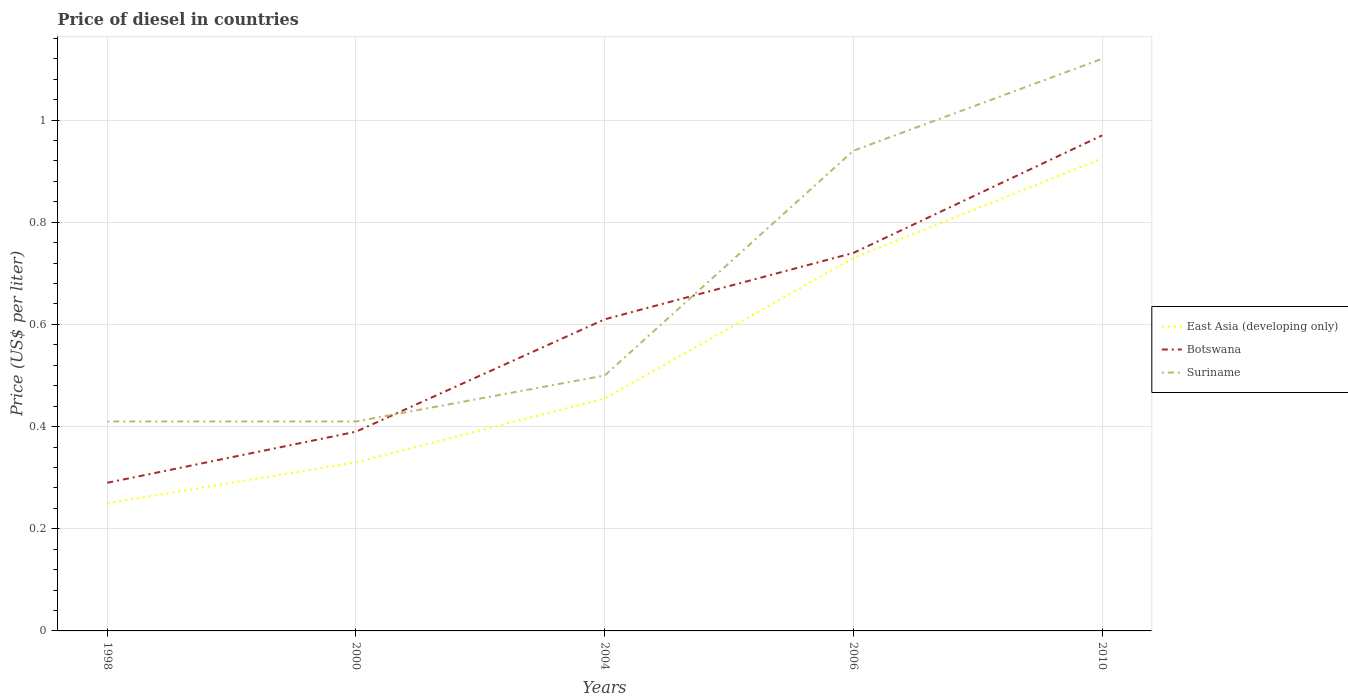Across all years, what is the maximum price of diesel in Botswana?
Your response must be concise. 0.29. What is the total price of diesel in East Asia (developing only) in the graph?
Keep it short and to the point. -0.59. What is the difference between the highest and the second highest price of diesel in Suriname?
Provide a succinct answer. 0.71. How many lines are there?
Give a very brief answer. 3. Does the graph contain any zero values?
Offer a terse response. No. Does the graph contain grids?
Offer a very short reply. Yes. Where does the legend appear in the graph?
Keep it short and to the point. Center right. How are the legend labels stacked?
Offer a terse response. Vertical. What is the title of the graph?
Your response must be concise. Price of diesel in countries. Does "Sao Tome and Principe" appear as one of the legend labels in the graph?
Your response must be concise. No. What is the label or title of the X-axis?
Offer a terse response. Years. What is the label or title of the Y-axis?
Offer a terse response. Price (US$ per liter). What is the Price (US$ per liter) of Botswana in 1998?
Offer a terse response. 0.29. What is the Price (US$ per liter) in Suriname in 1998?
Your answer should be compact. 0.41. What is the Price (US$ per liter) in East Asia (developing only) in 2000?
Offer a very short reply. 0.33. What is the Price (US$ per liter) in Botswana in 2000?
Ensure brevity in your answer.  0.39. What is the Price (US$ per liter) in Suriname in 2000?
Provide a succinct answer. 0.41. What is the Price (US$ per liter) of East Asia (developing only) in 2004?
Provide a succinct answer. 0.46. What is the Price (US$ per liter) in Botswana in 2004?
Provide a succinct answer. 0.61. What is the Price (US$ per liter) in East Asia (developing only) in 2006?
Provide a short and direct response. 0.73. What is the Price (US$ per liter) in Botswana in 2006?
Your answer should be compact. 0.74. What is the Price (US$ per liter) of Suriname in 2006?
Offer a very short reply. 0.94. What is the Price (US$ per liter) of East Asia (developing only) in 2010?
Your answer should be very brief. 0.93. What is the Price (US$ per liter) of Botswana in 2010?
Your response must be concise. 0.97. What is the Price (US$ per liter) of Suriname in 2010?
Ensure brevity in your answer.  1.12. Across all years, what is the maximum Price (US$ per liter) of East Asia (developing only)?
Offer a very short reply. 0.93. Across all years, what is the maximum Price (US$ per liter) of Suriname?
Offer a very short reply. 1.12. Across all years, what is the minimum Price (US$ per liter) in East Asia (developing only)?
Your answer should be very brief. 0.25. Across all years, what is the minimum Price (US$ per liter) in Botswana?
Your answer should be compact. 0.29. Across all years, what is the minimum Price (US$ per liter) of Suriname?
Ensure brevity in your answer.  0.41. What is the total Price (US$ per liter) in East Asia (developing only) in the graph?
Give a very brief answer. 2.69. What is the total Price (US$ per liter) in Botswana in the graph?
Provide a succinct answer. 3. What is the total Price (US$ per liter) in Suriname in the graph?
Make the answer very short. 3.38. What is the difference between the Price (US$ per liter) in East Asia (developing only) in 1998 and that in 2000?
Offer a very short reply. -0.08. What is the difference between the Price (US$ per liter) of Suriname in 1998 and that in 2000?
Your answer should be very brief. 0. What is the difference between the Price (US$ per liter) of East Asia (developing only) in 1998 and that in 2004?
Keep it short and to the point. -0.2. What is the difference between the Price (US$ per liter) of Botswana in 1998 and that in 2004?
Your answer should be compact. -0.32. What is the difference between the Price (US$ per liter) of Suriname in 1998 and that in 2004?
Give a very brief answer. -0.09. What is the difference between the Price (US$ per liter) of East Asia (developing only) in 1998 and that in 2006?
Provide a short and direct response. -0.48. What is the difference between the Price (US$ per liter) in Botswana in 1998 and that in 2006?
Provide a succinct answer. -0.45. What is the difference between the Price (US$ per liter) in Suriname in 1998 and that in 2006?
Provide a succinct answer. -0.53. What is the difference between the Price (US$ per liter) of East Asia (developing only) in 1998 and that in 2010?
Give a very brief answer. -0.68. What is the difference between the Price (US$ per liter) of Botswana in 1998 and that in 2010?
Your answer should be compact. -0.68. What is the difference between the Price (US$ per liter) in Suriname in 1998 and that in 2010?
Your answer should be very brief. -0.71. What is the difference between the Price (US$ per liter) of East Asia (developing only) in 2000 and that in 2004?
Keep it short and to the point. -0.12. What is the difference between the Price (US$ per liter) of Botswana in 2000 and that in 2004?
Your response must be concise. -0.22. What is the difference between the Price (US$ per liter) in Suriname in 2000 and that in 2004?
Offer a very short reply. -0.09. What is the difference between the Price (US$ per liter) in East Asia (developing only) in 2000 and that in 2006?
Provide a short and direct response. -0.4. What is the difference between the Price (US$ per liter) of Botswana in 2000 and that in 2006?
Offer a terse response. -0.35. What is the difference between the Price (US$ per liter) of Suriname in 2000 and that in 2006?
Your answer should be very brief. -0.53. What is the difference between the Price (US$ per liter) of East Asia (developing only) in 2000 and that in 2010?
Your answer should be very brief. -0.59. What is the difference between the Price (US$ per liter) of Botswana in 2000 and that in 2010?
Keep it short and to the point. -0.58. What is the difference between the Price (US$ per liter) in Suriname in 2000 and that in 2010?
Keep it short and to the point. -0.71. What is the difference between the Price (US$ per liter) in East Asia (developing only) in 2004 and that in 2006?
Provide a short and direct response. -0.28. What is the difference between the Price (US$ per liter) in Botswana in 2004 and that in 2006?
Ensure brevity in your answer.  -0.13. What is the difference between the Price (US$ per liter) in Suriname in 2004 and that in 2006?
Keep it short and to the point. -0.44. What is the difference between the Price (US$ per liter) of East Asia (developing only) in 2004 and that in 2010?
Provide a succinct answer. -0.47. What is the difference between the Price (US$ per liter) in Botswana in 2004 and that in 2010?
Your response must be concise. -0.36. What is the difference between the Price (US$ per liter) of Suriname in 2004 and that in 2010?
Your answer should be compact. -0.62. What is the difference between the Price (US$ per liter) in East Asia (developing only) in 2006 and that in 2010?
Give a very brief answer. -0.2. What is the difference between the Price (US$ per liter) in Botswana in 2006 and that in 2010?
Keep it short and to the point. -0.23. What is the difference between the Price (US$ per liter) of Suriname in 2006 and that in 2010?
Your answer should be compact. -0.18. What is the difference between the Price (US$ per liter) in East Asia (developing only) in 1998 and the Price (US$ per liter) in Botswana in 2000?
Give a very brief answer. -0.14. What is the difference between the Price (US$ per liter) of East Asia (developing only) in 1998 and the Price (US$ per liter) of Suriname in 2000?
Offer a terse response. -0.16. What is the difference between the Price (US$ per liter) of Botswana in 1998 and the Price (US$ per liter) of Suriname in 2000?
Your answer should be compact. -0.12. What is the difference between the Price (US$ per liter) in East Asia (developing only) in 1998 and the Price (US$ per liter) in Botswana in 2004?
Provide a succinct answer. -0.36. What is the difference between the Price (US$ per liter) of Botswana in 1998 and the Price (US$ per liter) of Suriname in 2004?
Your response must be concise. -0.21. What is the difference between the Price (US$ per liter) of East Asia (developing only) in 1998 and the Price (US$ per liter) of Botswana in 2006?
Provide a succinct answer. -0.49. What is the difference between the Price (US$ per liter) of East Asia (developing only) in 1998 and the Price (US$ per liter) of Suriname in 2006?
Ensure brevity in your answer.  -0.69. What is the difference between the Price (US$ per liter) in Botswana in 1998 and the Price (US$ per liter) in Suriname in 2006?
Your answer should be very brief. -0.65. What is the difference between the Price (US$ per liter) in East Asia (developing only) in 1998 and the Price (US$ per liter) in Botswana in 2010?
Give a very brief answer. -0.72. What is the difference between the Price (US$ per liter) in East Asia (developing only) in 1998 and the Price (US$ per liter) in Suriname in 2010?
Offer a terse response. -0.87. What is the difference between the Price (US$ per liter) in Botswana in 1998 and the Price (US$ per liter) in Suriname in 2010?
Your answer should be very brief. -0.83. What is the difference between the Price (US$ per liter) in East Asia (developing only) in 2000 and the Price (US$ per liter) in Botswana in 2004?
Your answer should be compact. -0.28. What is the difference between the Price (US$ per liter) in East Asia (developing only) in 2000 and the Price (US$ per liter) in Suriname in 2004?
Make the answer very short. -0.17. What is the difference between the Price (US$ per liter) of Botswana in 2000 and the Price (US$ per liter) of Suriname in 2004?
Provide a succinct answer. -0.11. What is the difference between the Price (US$ per liter) of East Asia (developing only) in 2000 and the Price (US$ per liter) of Botswana in 2006?
Make the answer very short. -0.41. What is the difference between the Price (US$ per liter) of East Asia (developing only) in 2000 and the Price (US$ per liter) of Suriname in 2006?
Ensure brevity in your answer.  -0.61. What is the difference between the Price (US$ per liter) of Botswana in 2000 and the Price (US$ per liter) of Suriname in 2006?
Ensure brevity in your answer.  -0.55. What is the difference between the Price (US$ per liter) of East Asia (developing only) in 2000 and the Price (US$ per liter) of Botswana in 2010?
Ensure brevity in your answer.  -0.64. What is the difference between the Price (US$ per liter) in East Asia (developing only) in 2000 and the Price (US$ per liter) in Suriname in 2010?
Ensure brevity in your answer.  -0.79. What is the difference between the Price (US$ per liter) in Botswana in 2000 and the Price (US$ per liter) in Suriname in 2010?
Ensure brevity in your answer.  -0.73. What is the difference between the Price (US$ per liter) of East Asia (developing only) in 2004 and the Price (US$ per liter) of Botswana in 2006?
Ensure brevity in your answer.  -0.28. What is the difference between the Price (US$ per liter) of East Asia (developing only) in 2004 and the Price (US$ per liter) of Suriname in 2006?
Offer a very short reply. -0.48. What is the difference between the Price (US$ per liter) in Botswana in 2004 and the Price (US$ per liter) in Suriname in 2006?
Your answer should be compact. -0.33. What is the difference between the Price (US$ per liter) of East Asia (developing only) in 2004 and the Price (US$ per liter) of Botswana in 2010?
Your answer should be very brief. -0.52. What is the difference between the Price (US$ per liter) in East Asia (developing only) in 2004 and the Price (US$ per liter) in Suriname in 2010?
Provide a short and direct response. -0.67. What is the difference between the Price (US$ per liter) in Botswana in 2004 and the Price (US$ per liter) in Suriname in 2010?
Provide a succinct answer. -0.51. What is the difference between the Price (US$ per liter) of East Asia (developing only) in 2006 and the Price (US$ per liter) of Botswana in 2010?
Your answer should be very brief. -0.24. What is the difference between the Price (US$ per liter) in East Asia (developing only) in 2006 and the Price (US$ per liter) in Suriname in 2010?
Your response must be concise. -0.39. What is the difference between the Price (US$ per liter) of Botswana in 2006 and the Price (US$ per liter) of Suriname in 2010?
Ensure brevity in your answer.  -0.38. What is the average Price (US$ per liter) of East Asia (developing only) per year?
Your response must be concise. 0.54. What is the average Price (US$ per liter) in Suriname per year?
Provide a short and direct response. 0.68. In the year 1998, what is the difference between the Price (US$ per liter) of East Asia (developing only) and Price (US$ per liter) of Botswana?
Keep it short and to the point. -0.04. In the year 1998, what is the difference between the Price (US$ per liter) in East Asia (developing only) and Price (US$ per liter) in Suriname?
Offer a terse response. -0.16. In the year 1998, what is the difference between the Price (US$ per liter) of Botswana and Price (US$ per liter) of Suriname?
Your answer should be compact. -0.12. In the year 2000, what is the difference between the Price (US$ per liter) of East Asia (developing only) and Price (US$ per liter) of Botswana?
Make the answer very short. -0.06. In the year 2000, what is the difference between the Price (US$ per liter) in East Asia (developing only) and Price (US$ per liter) in Suriname?
Give a very brief answer. -0.08. In the year 2000, what is the difference between the Price (US$ per liter) in Botswana and Price (US$ per liter) in Suriname?
Offer a terse response. -0.02. In the year 2004, what is the difference between the Price (US$ per liter) in East Asia (developing only) and Price (US$ per liter) in Botswana?
Your answer should be compact. -0.15. In the year 2004, what is the difference between the Price (US$ per liter) of East Asia (developing only) and Price (US$ per liter) of Suriname?
Offer a very short reply. -0.04. In the year 2004, what is the difference between the Price (US$ per liter) of Botswana and Price (US$ per liter) of Suriname?
Ensure brevity in your answer.  0.11. In the year 2006, what is the difference between the Price (US$ per liter) in East Asia (developing only) and Price (US$ per liter) in Botswana?
Ensure brevity in your answer.  -0.01. In the year 2006, what is the difference between the Price (US$ per liter) in East Asia (developing only) and Price (US$ per liter) in Suriname?
Make the answer very short. -0.21. In the year 2006, what is the difference between the Price (US$ per liter) in Botswana and Price (US$ per liter) in Suriname?
Your answer should be compact. -0.2. In the year 2010, what is the difference between the Price (US$ per liter) of East Asia (developing only) and Price (US$ per liter) of Botswana?
Make the answer very short. -0.04. In the year 2010, what is the difference between the Price (US$ per liter) in East Asia (developing only) and Price (US$ per liter) in Suriname?
Your response must be concise. -0.2. In the year 2010, what is the difference between the Price (US$ per liter) of Botswana and Price (US$ per liter) of Suriname?
Offer a terse response. -0.15. What is the ratio of the Price (US$ per liter) of East Asia (developing only) in 1998 to that in 2000?
Your response must be concise. 0.76. What is the ratio of the Price (US$ per liter) of Botswana in 1998 to that in 2000?
Make the answer very short. 0.74. What is the ratio of the Price (US$ per liter) in Suriname in 1998 to that in 2000?
Your answer should be very brief. 1. What is the ratio of the Price (US$ per liter) in East Asia (developing only) in 1998 to that in 2004?
Ensure brevity in your answer.  0.55. What is the ratio of the Price (US$ per liter) in Botswana in 1998 to that in 2004?
Keep it short and to the point. 0.48. What is the ratio of the Price (US$ per liter) in Suriname in 1998 to that in 2004?
Your response must be concise. 0.82. What is the ratio of the Price (US$ per liter) in East Asia (developing only) in 1998 to that in 2006?
Give a very brief answer. 0.34. What is the ratio of the Price (US$ per liter) in Botswana in 1998 to that in 2006?
Make the answer very short. 0.39. What is the ratio of the Price (US$ per liter) in Suriname in 1998 to that in 2006?
Provide a succinct answer. 0.44. What is the ratio of the Price (US$ per liter) of East Asia (developing only) in 1998 to that in 2010?
Your answer should be compact. 0.27. What is the ratio of the Price (US$ per liter) in Botswana in 1998 to that in 2010?
Your answer should be compact. 0.3. What is the ratio of the Price (US$ per liter) of Suriname in 1998 to that in 2010?
Offer a terse response. 0.37. What is the ratio of the Price (US$ per liter) of East Asia (developing only) in 2000 to that in 2004?
Your answer should be compact. 0.73. What is the ratio of the Price (US$ per liter) in Botswana in 2000 to that in 2004?
Provide a short and direct response. 0.64. What is the ratio of the Price (US$ per liter) of Suriname in 2000 to that in 2004?
Keep it short and to the point. 0.82. What is the ratio of the Price (US$ per liter) of East Asia (developing only) in 2000 to that in 2006?
Offer a very short reply. 0.45. What is the ratio of the Price (US$ per liter) in Botswana in 2000 to that in 2006?
Give a very brief answer. 0.53. What is the ratio of the Price (US$ per liter) in Suriname in 2000 to that in 2006?
Provide a short and direct response. 0.44. What is the ratio of the Price (US$ per liter) in East Asia (developing only) in 2000 to that in 2010?
Your answer should be very brief. 0.36. What is the ratio of the Price (US$ per liter) of Botswana in 2000 to that in 2010?
Your answer should be compact. 0.4. What is the ratio of the Price (US$ per liter) in Suriname in 2000 to that in 2010?
Provide a short and direct response. 0.37. What is the ratio of the Price (US$ per liter) in East Asia (developing only) in 2004 to that in 2006?
Provide a short and direct response. 0.62. What is the ratio of the Price (US$ per liter) in Botswana in 2004 to that in 2006?
Make the answer very short. 0.82. What is the ratio of the Price (US$ per liter) in Suriname in 2004 to that in 2006?
Your answer should be compact. 0.53. What is the ratio of the Price (US$ per liter) in East Asia (developing only) in 2004 to that in 2010?
Give a very brief answer. 0.49. What is the ratio of the Price (US$ per liter) in Botswana in 2004 to that in 2010?
Make the answer very short. 0.63. What is the ratio of the Price (US$ per liter) of Suriname in 2004 to that in 2010?
Keep it short and to the point. 0.45. What is the ratio of the Price (US$ per liter) of East Asia (developing only) in 2006 to that in 2010?
Give a very brief answer. 0.79. What is the ratio of the Price (US$ per liter) of Botswana in 2006 to that in 2010?
Your answer should be very brief. 0.76. What is the ratio of the Price (US$ per liter) of Suriname in 2006 to that in 2010?
Your answer should be very brief. 0.84. What is the difference between the highest and the second highest Price (US$ per liter) in East Asia (developing only)?
Your response must be concise. 0.2. What is the difference between the highest and the second highest Price (US$ per liter) of Botswana?
Offer a terse response. 0.23. What is the difference between the highest and the second highest Price (US$ per liter) of Suriname?
Make the answer very short. 0.18. What is the difference between the highest and the lowest Price (US$ per liter) of East Asia (developing only)?
Make the answer very short. 0.68. What is the difference between the highest and the lowest Price (US$ per liter) of Botswana?
Provide a short and direct response. 0.68. What is the difference between the highest and the lowest Price (US$ per liter) in Suriname?
Your answer should be compact. 0.71. 